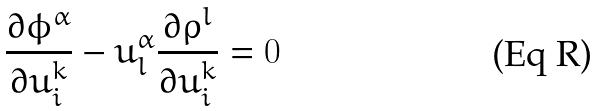<formula> <loc_0><loc_0><loc_500><loc_500>\frac { \partial \phi ^ { \alpha } } { \partial u _ { i } ^ { k } } - u _ { l } ^ { \alpha } \frac { \partial \rho ^ { l } } { \partial u _ { i } ^ { k } } = 0</formula> 